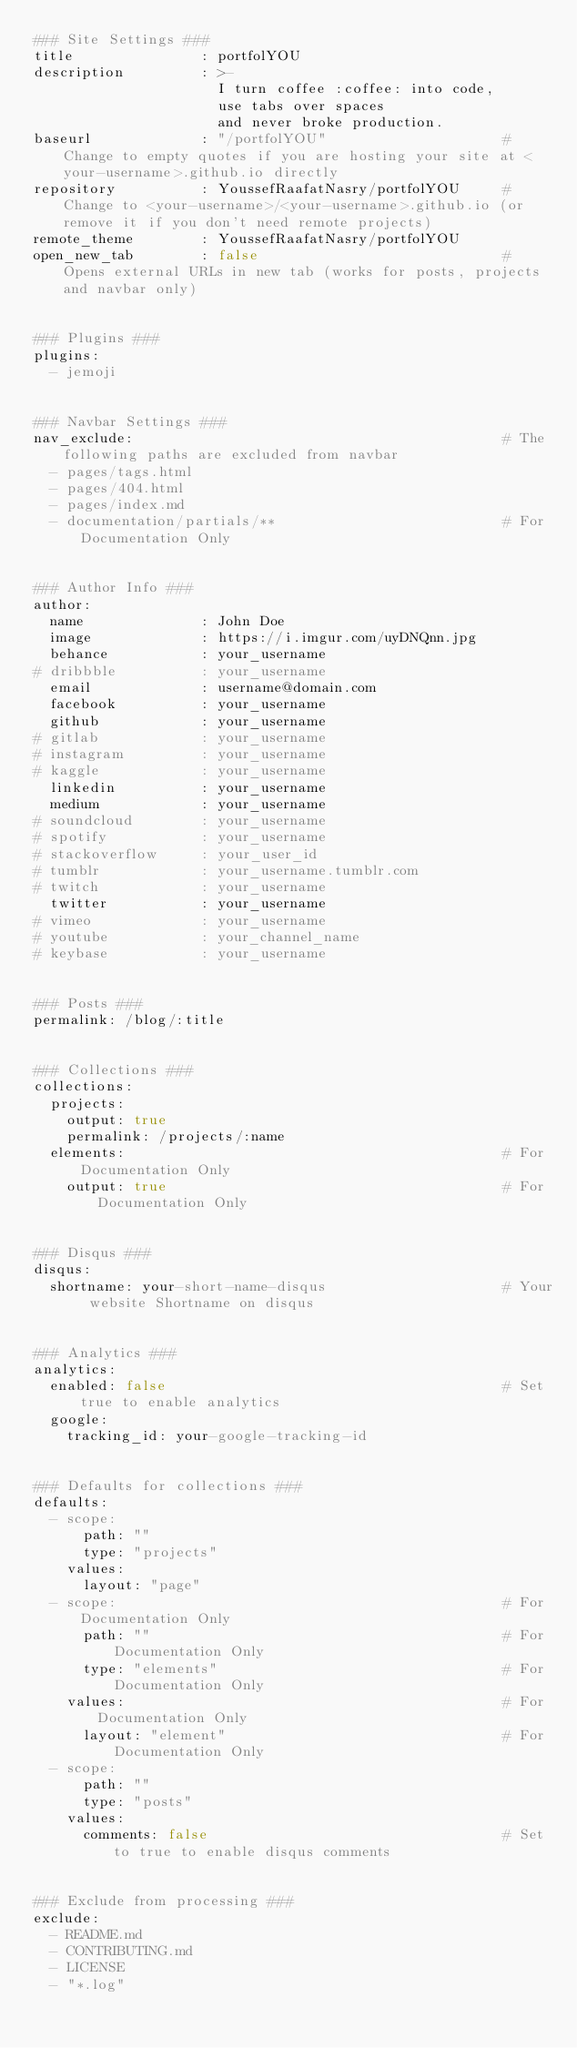<code> <loc_0><loc_0><loc_500><loc_500><_YAML_>### Site Settings ###
title               : portfolYOU
description         : >-
                      I turn coffee :coffee: into code,
                      use tabs over spaces
                      and never broke production.
baseurl             : "/portfolYOU"                     # Change to empty quotes if you are hosting your site at <your-username>.github.io directly
repository          : YoussefRaafatNasry/portfolYOU     # Change to <your-username>/<your-username>.github.io (or remove it if you don't need remote projects)
remote_theme        : YoussefRaafatNasry/portfolYOU
open_new_tab        : false                             # Opens external URLs in new tab (works for posts, projects and navbar only)


### Plugins ###
plugins:
  - jemoji


### Navbar Settings ###
nav_exclude:                                            # The following paths are excluded from navbar
  - pages/tags.html
  - pages/404.html
  - pages/index.md
  - documentation/partials/**                           # For Documentation Only


### Author Info ###
author:
  name              : John Doe
  image             : https://i.imgur.com/uyDNQnn.jpg
  behance           : your_username
# dribbble          : your_username
  email             : username@domain.com
  facebook          : your_username
  github            : your_username
# gitlab            : your_username
# instagram         : your_username
# kaggle            : your_username
  linkedin          : your_username
  medium            : your_username
# soundcloud        : your_username
# spotify           : your_username
# stackoverflow     : your_user_id
# tumblr            : your_username.tumblr.com
# twitch            : your_username
  twitter           : your_username
# vimeo             : your_username
# youtube           : your_channel_name
# keybase           : your_username


### Posts ###
permalink: /blog/:title


### Collections ###
collections:
  projects:
    output: true
    permalink: /projects/:name
  elements:                                             # For Documentation Only
    output: true                                        # For Documentation Only


### Disqus ###
disqus:
  shortname: your-short-name-disqus                     # Your website Shortname on disqus


### Analytics ###
analytics:
  enabled: false                                        # Set true to enable analytics
  google:
    tracking_id: your-google-tracking-id


### Defaults for collections ###
defaults:
  - scope:
      path: ""
      type: "projects"
    values:
      layout: "page"
  - scope:                                              # For Documentation Only
      path: ""                                          # For Documentation Only
      type: "elements"                                  # For Documentation Only
    values:                                             # For Documentation Only
      layout: "element"                                 # For Documentation Only
  - scope:
      path: ""
      type: "posts"
    values:
      comments: false                                   # Set to true to enable disqus comments


### Exclude from processing ###
exclude:
  - README.md
  - CONTRIBUTING.md
  - LICENSE
  - "*.log"
</code> 